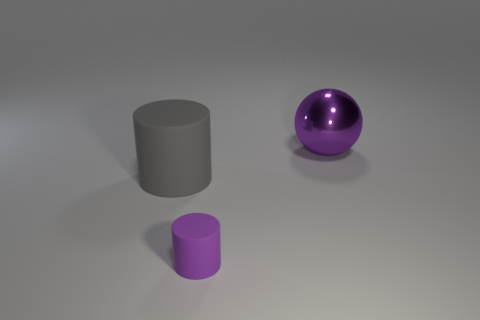Add 1 gray metallic objects. How many objects exist? 4 Subtract all balls. How many objects are left? 2 Add 2 gray cylinders. How many gray cylinders exist? 3 Subtract 0 yellow spheres. How many objects are left? 3 Subtract all gray cylinders. Subtract all small purple rubber objects. How many objects are left? 1 Add 3 big gray rubber things. How many big gray rubber things are left? 4 